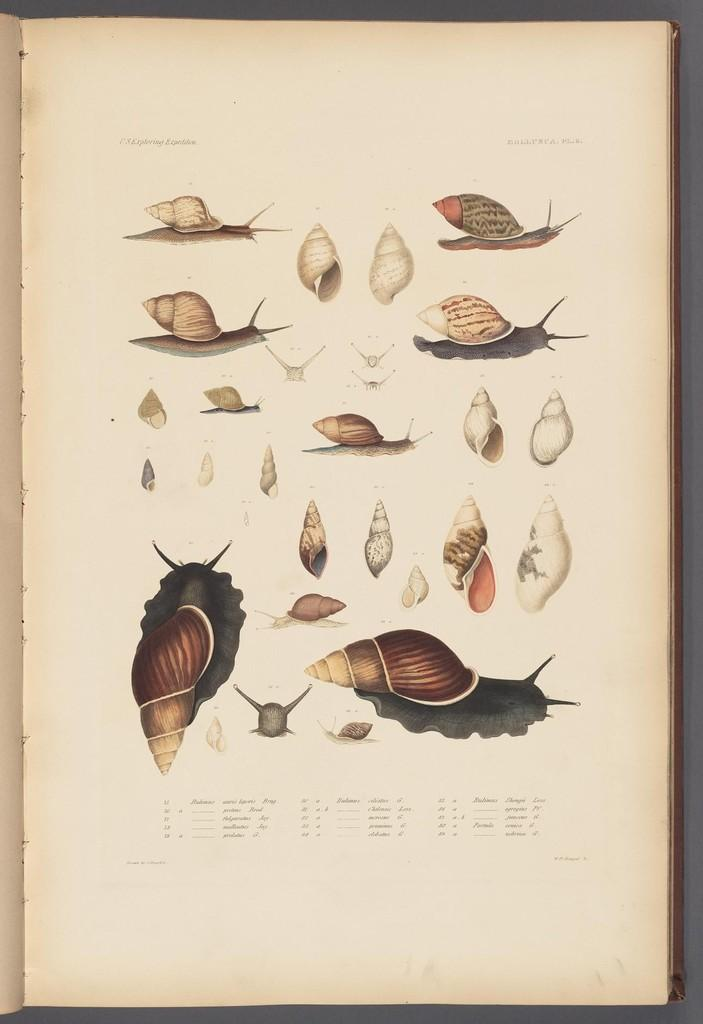What is present in the image related to reading material? There is a book in the image. What can be found within the book? The book has text and images. What is the color of the surface the book is placed on? The surface the book is on is white. Is the book sinking into quicksand in the image? There is no quicksand present in the image, so the book is not sinking into it. What need does the book fulfill in the image? The image does not provide information about the book fulfilling a specific need. 